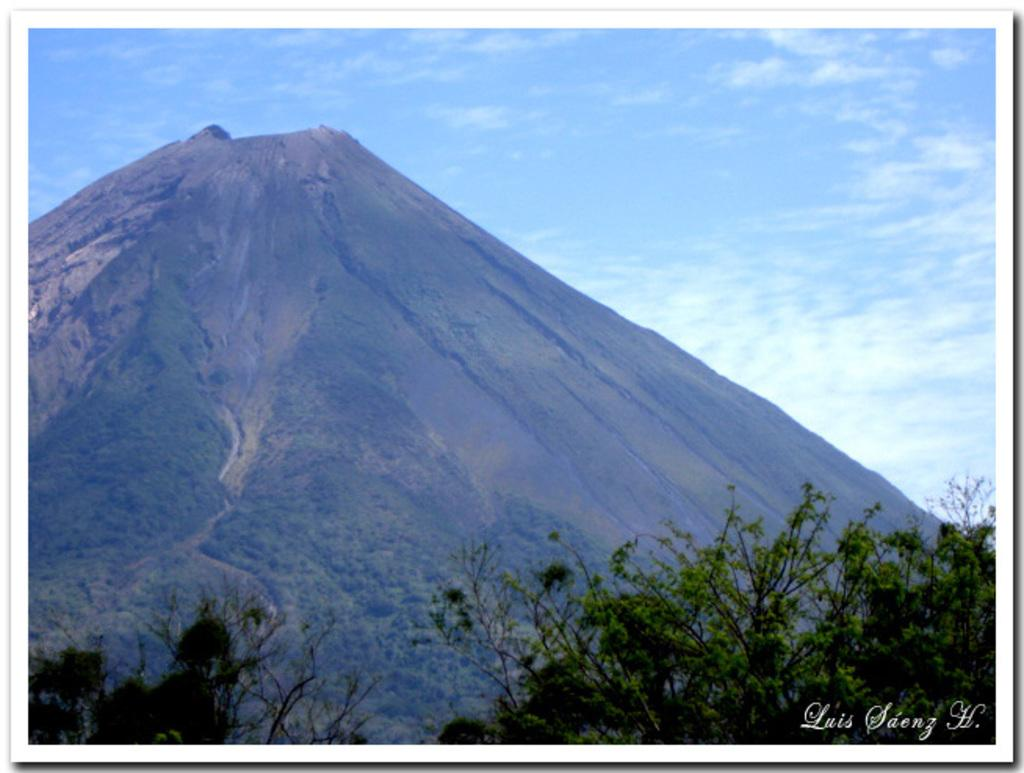What is located in the foreground of the image? There are trees in the foreground of the image. What is the main feature in the middle of the image? There is a mountain in the middle of the image. What can be seen in the background of the image? The sky and clouds are visible in the background of the image. How far away is the yoke from the trees in the image? There is no yoke present in the image. What type of weather condition is depicted by the fog in the image? There is no fog present in the image; only clouds are visible in the background. 